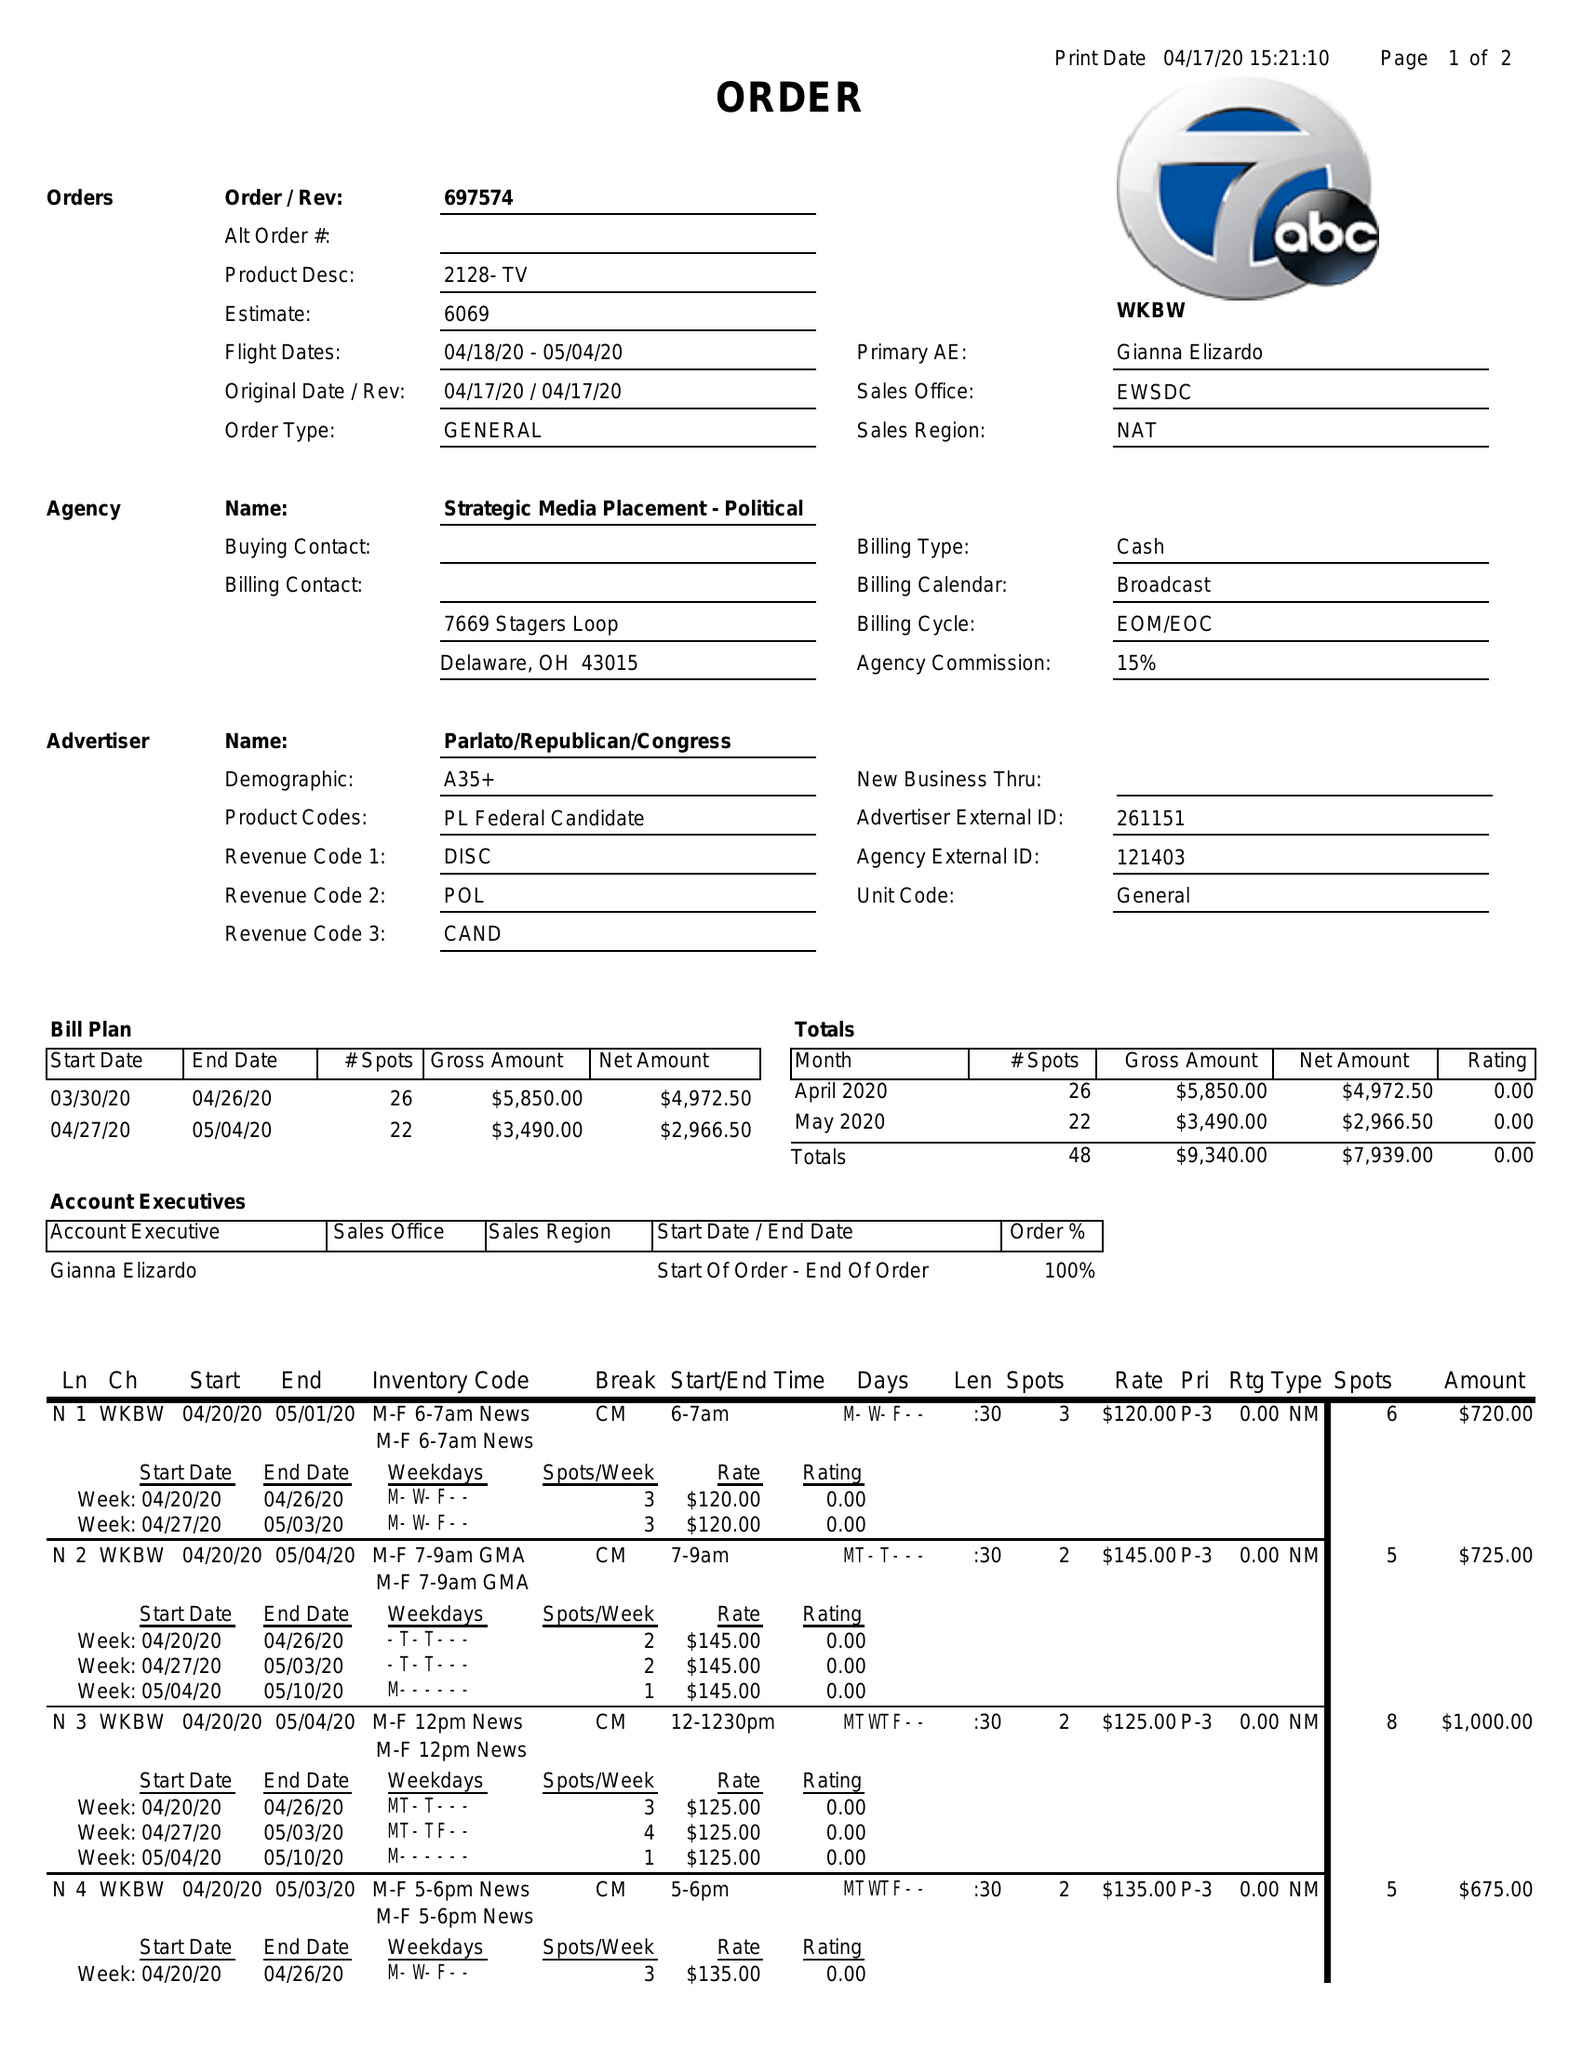What is the value for the flight_from?
Answer the question using a single word or phrase. 04/18/20 